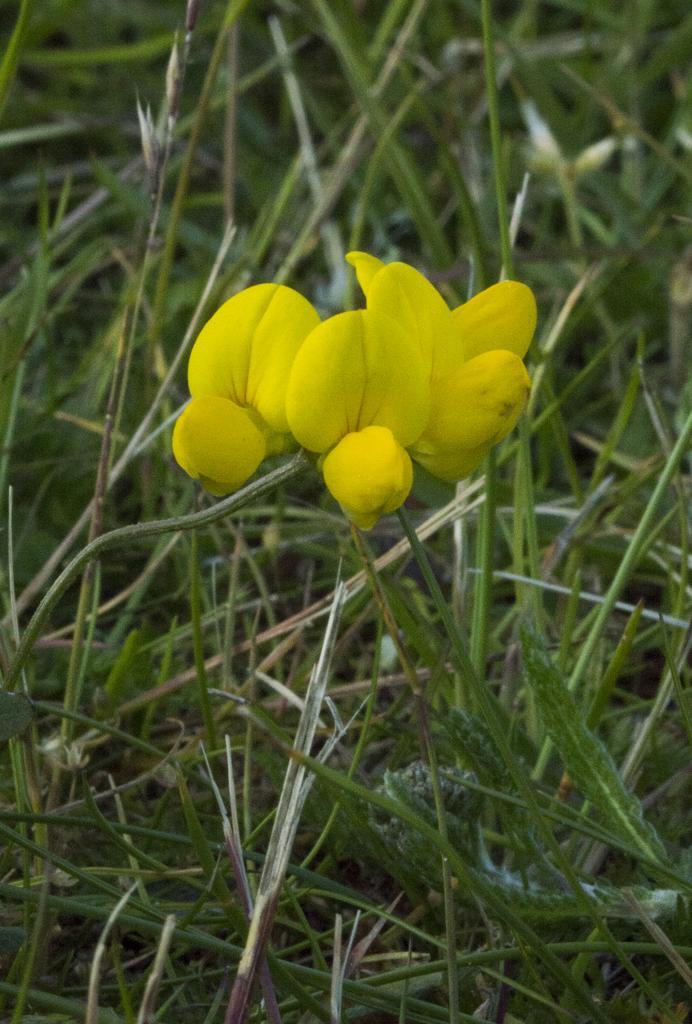Can you describe this image briefly? In the middle of the picture, we see the flowers in yellow color. In the background, we see the grass. This picture is blurred in the background. 